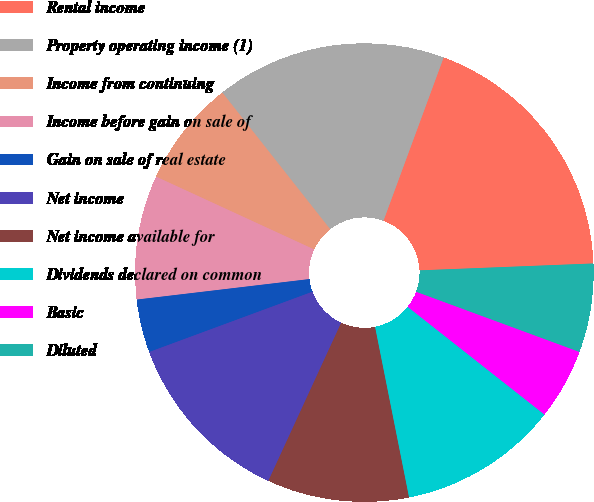<chart> <loc_0><loc_0><loc_500><loc_500><pie_chart><fcel>Rental income<fcel>Property operating income (1)<fcel>Income from continuing<fcel>Income before gain on sale of<fcel>Gain on sale of real estate<fcel>Net income<fcel>Net income available for<fcel>Dividends declared on common<fcel>Basic<fcel>Diluted<nl><fcel>18.75%<fcel>16.25%<fcel>7.5%<fcel>8.75%<fcel>3.75%<fcel>12.5%<fcel>10.0%<fcel>11.25%<fcel>5.0%<fcel>6.25%<nl></chart> 